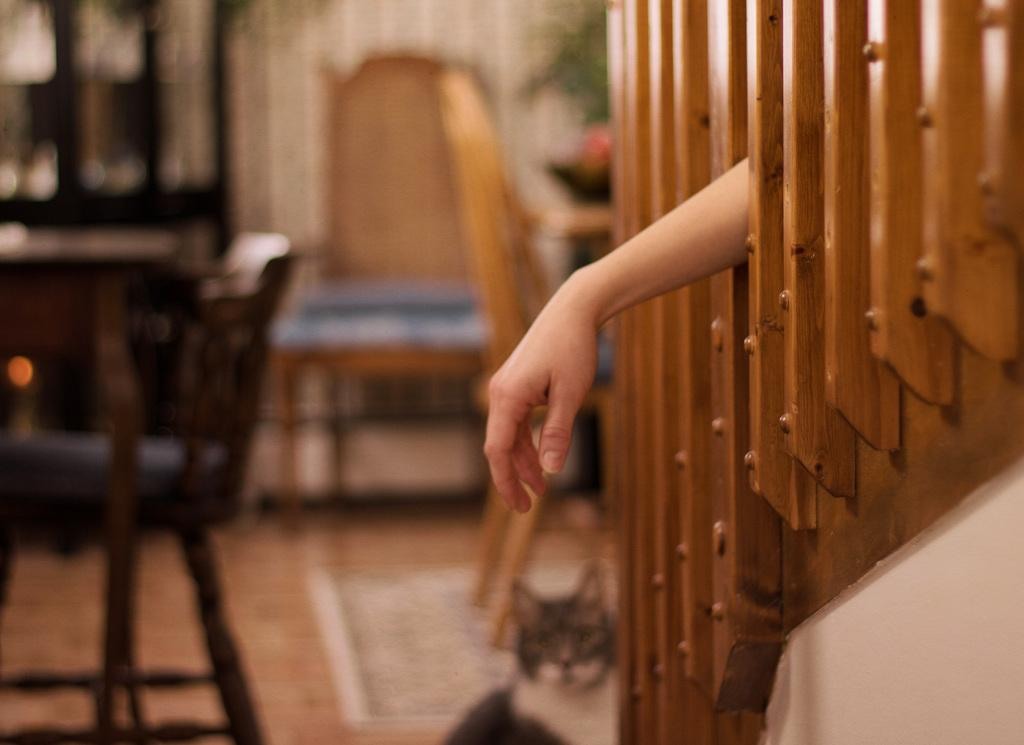What type of space is depicted in the image? There is a room in the image. What furniture can be seen in the background of the room? There is a table and chairs in the background of the image. What object is present near the table and chairs? There is a wooden stick in the background of the image. What part of a person is visible in the center of the image? There is a human hand in the center of the image. What is the profit generated by the wooden stick in the image? There is no information about profit in the image, as it is focused on the room, furniture, and human hand. 